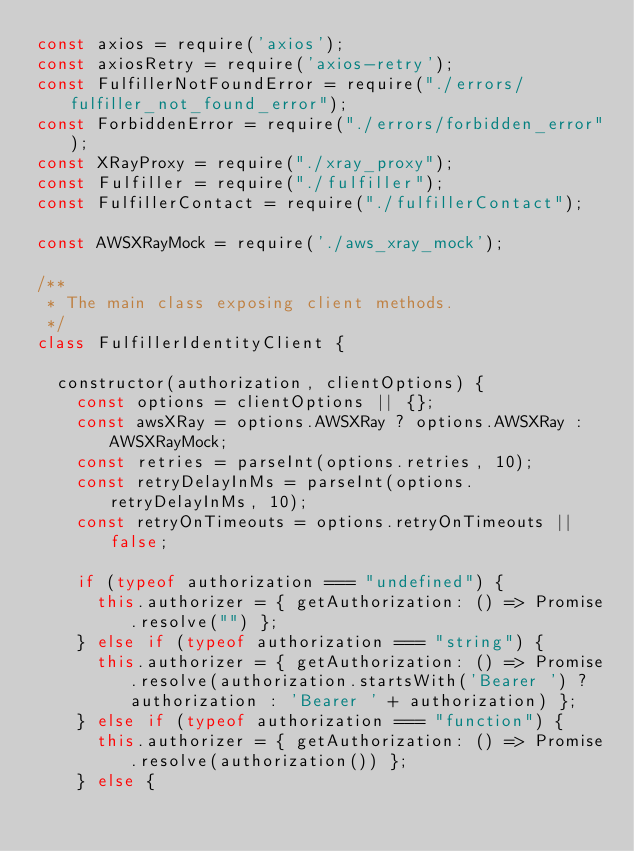<code> <loc_0><loc_0><loc_500><loc_500><_JavaScript_>const axios = require('axios');
const axiosRetry = require('axios-retry');
const FulfillerNotFoundError = require("./errors/fulfiller_not_found_error");
const ForbiddenError = require("./errors/forbidden_error");
const XRayProxy = require("./xray_proxy");
const Fulfiller = require("./fulfiller");
const FulfillerContact = require("./fulfillerContact");

const AWSXRayMock = require('./aws_xray_mock');

/**
 * The main class exposing client methods.
 */
class FulfillerIdentityClient {

  constructor(authorization, clientOptions) {
    const options = clientOptions || {};
    const awsXRay = options.AWSXRay ? options.AWSXRay : AWSXRayMock;
    const retries = parseInt(options.retries, 10);
    const retryDelayInMs = parseInt(options.retryDelayInMs, 10);
    const retryOnTimeouts = options.retryOnTimeouts || false;

    if (typeof authorization === "undefined") {
      this.authorizer = { getAuthorization: () => Promise.resolve("") };
    } else if (typeof authorization === "string") {
      this.authorizer = { getAuthorization: () => Promise.resolve(authorization.startsWith('Bearer ') ? authorization : 'Bearer ' + authorization) };
    } else if (typeof authorization === "function") {
      this.authorizer = { getAuthorization: () => Promise.resolve(authorization()) };
    } else {</code> 